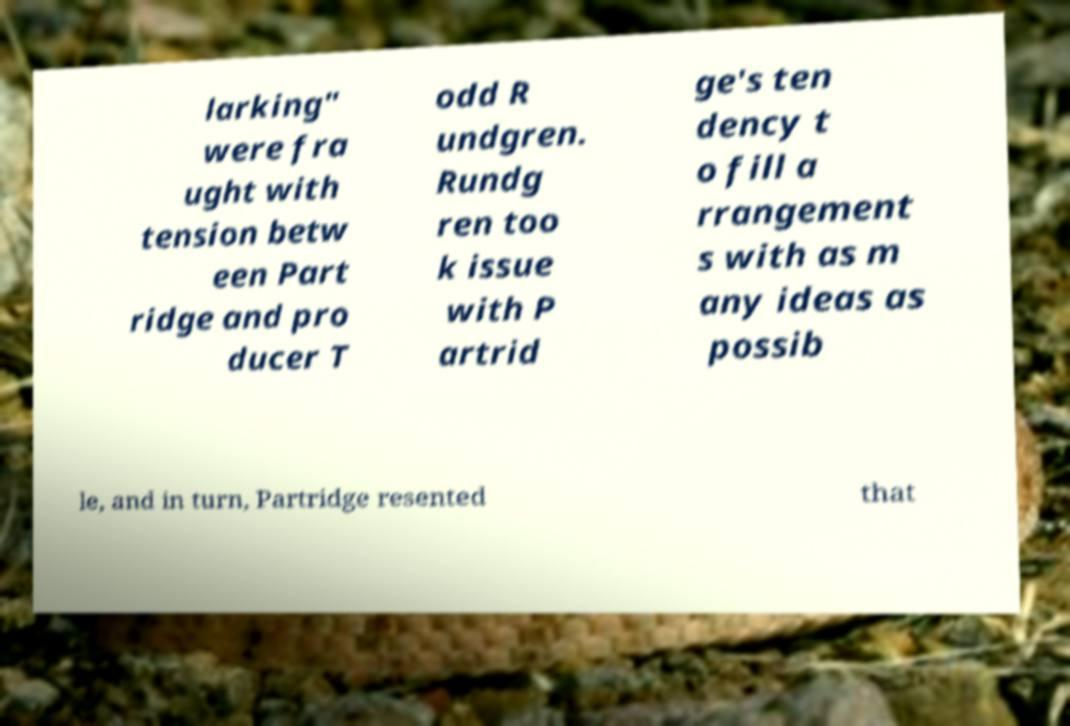What messages or text are displayed in this image? I need them in a readable, typed format. larking" were fra ught with tension betw een Part ridge and pro ducer T odd R undgren. Rundg ren too k issue with P artrid ge's ten dency t o fill a rrangement s with as m any ideas as possib le, and in turn, Partridge resented that 